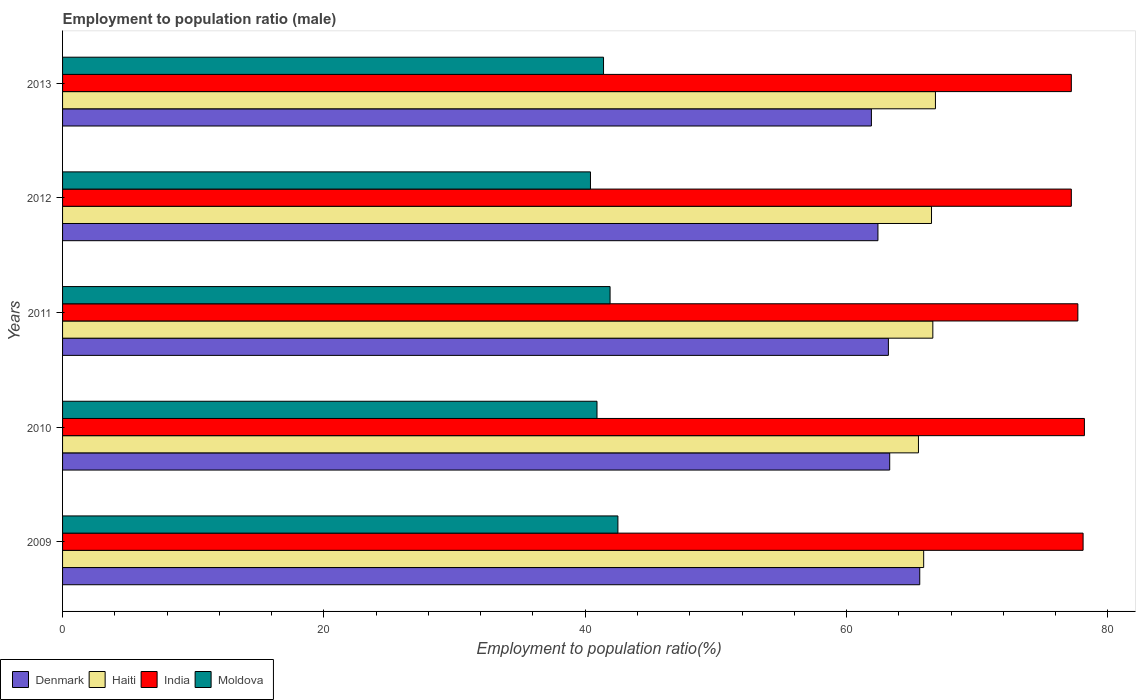How many different coloured bars are there?
Keep it short and to the point. 4. How many groups of bars are there?
Give a very brief answer. 5. Are the number of bars on each tick of the Y-axis equal?
Give a very brief answer. Yes. What is the label of the 3rd group of bars from the top?
Provide a short and direct response. 2011. In how many cases, is the number of bars for a given year not equal to the number of legend labels?
Your answer should be compact. 0. What is the employment to population ratio in Haiti in 2010?
Your response must be concise. 65.5. Across all years, what is the maximum employment to population ratio in India?
Make the answer very short. 78.2. Across all years, what is the minimum employment to population ratio in Haiti?
Ensure brevity in your answer.  65.5. What is the total employment to population ratio in Denmark in the graph?
Your answer should be very brief. 316.4. What is the difference between the employment to population ratio in Haiti in 2010 and that in 2013?
Provide a succinct answer. -1.3. What is the difference between the employment to population ratio in Haiti in 2010 and the employment to population ratio in Denmark in 2013?
Your response must be concise. 3.6. What is the average employment to population ratio in Haiti per year?
Make the answer very short. 66.26. In how many years, is the employment to population ratio in Denmark greater than 36 %?
Offer a terse response. 5. What is the ratio of the employment to population ratio in Denmark in 2009 to that in 2011?
Ensure brevity in your answer.  1.04. Is the employment to population ratio in Haiti in 2009 less than that in 2011?
Make the answer very short. Yes. Is the difference between the employment to population ratio in Denmark in 2010 and 2013 greater than the difference between the employment to population ratio in Moldova in 2010 and 2013?
Ensure brevity in your answer.  Yes. What is the difference between the highest and the second highest employment to population ratio in Denmark?
Provide a short and direct response. 2.3. What is the difference between the highest and the lowest employment to population ratio in Moldova?
Your answer should be very brief. 2.1. In how many years, is the employment to population ratio in India greater than the average employment to population ratio in India taken over all years?
Provide a short and direct response. 3. Is the sum of the employment to population ratio in India in 2009 and 2013 greater than the maximum employment to population ratio in Denmark across all years?
Offer a terse response. Yes. What does the 2nd bar from the top in 2009 represents?
Your answer should be very brief. India. What does the 1st bar from the bottom in 2010 represents?
Offer a very short reply. Denmark. Are all the bars in the graph horizontal?
Give a very brief answer. Yes. How many years are there in the graph?
Make the answer very short. 5. Does the graph contain any zero values?
Offer a terse response. No. Does the graph contain grids?
Offer a very short reply. No. How are the legend labels stacked?
Make the answer very short. Horizontal. What is the title of the graph?
Give a very brief answer. Employment to population ratio (male). Does "Sub-Saharan Africa (developing only)" appear as one of the legend labels in the graph?
Provide a succinct answer. No. What is the label or title of the X-axis?
Your response must be concise. Employment to population ratio(%). What is the Employment to population ratio(%) in Denmark in 2009?
Offer a terse response. 65.6. What is the Employment to population ratio(%) of Haiti in 2009?
Your answer should be very brief. 65.9. What is the Employment to population ratio(%) of India in 2009?
Your response must be concise. 78.1. What is the Employment to population ratio(%) in Moldova in 2009?
Offer a terse response. 42.5. What is the Employment to population ratio(%) of Denmark in 2010?
Offer a terse response. 63.3. What is the Employment to population ratio(%) of Haiti in 2010?
Your answer should be very brief. 65.5. What is the Employment to population ratio(%) of India in 2010?
Your response must be concise. 78.2. What is the Employment to population ratio(%) in Moldova in 2010?
Your answer should be very brief. 40.9. What is the Employment to population ratio(%) of Denmark in 2011?
Offer a very short reply. 63.2. What is the Employment to population ratio(%) in Haiti in 2011?
Offer a terse response. 66.6. What is the Employment to population ratio(%) of India in 2011?
Offer a very short reply. 77.7. What is the Employment to population ratio(%) of Moldova in 2011?
Your response must be concise. 41.9. What is the Employment to population ratio(%) of Denmark in 2012?
Keep it short and to the point. 62.4. What is the Employment to population ratio(%) of Haiti in 2012?
Your answer should be compact. 66.5. What is the Employment to population ratio(%) of India in 2012?
Make the answer very short. 77.2. What is the Employment to population ratio(%) of Moldova in 2012?
Provide a succinct answer. 40.4. What is the Employment to population ratio(%) of Denmark in 2013?
Keep it short and to the point. 61.9. What is the Employment to population ratio(%) of Haiti in 2013?
Provide a succinct answer. 66.8. What is the Employment to population ratio(%) of India in 2013?
Your answer should be compact. 77.2. What is the Employment to population ratio(%) in Moldova in 2013?
Your answer should be very brief. 41.4. Across all years, what is the maximum Employment to population ratio(%) of Denmark?
Offer a terse response. 65.6. Across all years, what is the maximum Employment to population ratio(%) of Haiti?
Make the answer very short. 66.8. Across all years, what is the maximum Employment to population ratio(%) of India?
Make the answer very short. 78.2. Across all years, what is the maximum Employment to population ratio(%) in Moldova?
Provide a succinct answer. 42.5. Across all years, what is the minimum Employment to population ratio(%) of Denmark?
Your answer should be compact. 61.9. Across all years, what is the minimum Employment to population ratio(%) in Haiti?
Your answer should be compact. 65.5. Across all years, what is the minimum Employment to population ratio(%) in India?
Provide a succinct answer. 77.2. Across all years, what is the minimum Employment to population ratio(%) of Moldova?
Your answer should be very brief. 40.4. What is the total Employment to population ratio(%) of Denmark in the graph?
Keep it short and to the point. 316.4. What is the total Employment to population ratio(%) of Haiti in the graph?
Keep it short and to the point. 331.3. What is the total Employment to population ratio(%) of India in the graph?
Give a very brief answer. 388.4. What is the total Employment to population ratio(%) of Moldova in the graph?
Provide a short and direct response. 207.1. What is the difference between the Employment to population ratio(%) in Denmark in 2009 and that in 2010?
Your response must be concise. 2.3. What is the difference between the Employment to population ratio(%) in Haiti in 2009 and that in 2011?
Provide a short and direct response. -0.7. What is the difference between the Employment to population ratio(%) in Denmark in 2009 and that in 2012?
Your answer should be very brief. 3.2. What is the difference between the Employment to population ratio(%) of Haiti in 2009 and that in 2012?
Your answer should be compact. -0.6. What is the difference between the Employment to population ratio(%) in Moldova in 2009 and that in 2012?
Offer a terse response. 2.1. What is the difference between the Employment to population ratio(%) in Denmark in 2009 and that in 2013?
Offer a very short reply. 3.7. What is the difference between the Employment to population ratio(%) in Denmark in 2010 and that in 2011?
Give a very brief answer. 0.1. What is the difference between the Employment to population ratio(%) in Haiti in 2010 and that in 2011?
Make the answer very short. -1.1. What is the difference between the Employment to population ratio(%) in India in 2010 and that in 2011?
Your answer should be very brief. 0.5. What is the difference between the Employment to population ratio(%) in Moldova in 2010 and that in 2011?
Provide a short and direct response. -1. What is the difference between the Employment to population ratio(%) in Denmark in 2010 and that in 2012?
Keep it short and to the point. 0.9. What is the difference between the Employment to population ratio(%) of India in 2010 and that in 2012?
Provide a succinct answer. 1. What is the difference between the Employment to population ratio(%) in Denmark in 2010 and that in 2013?
Your response must be concise. 1.4. What is the difference between the Employment to population ratio(%) of India in 2010 and that in 2013?
Offer a terse response. 1. What is the difference between the Employment to population ratio(%) of Denmark in 2011 and that in 2012?
Ensure brevity in your answer.  0.8. What is the difference between the Employment to population ratio(%) in Haiti in 2011 and that in 2012?
Offer a terse response. 0.1. What is the difference between the Employment to population ratio(%) in India in 2011 and that in 2012?
Keep it short and to the point. 0.5. What is the difference between the Employment to population ratio(%) in Moldova in 2011 and that in 2012?
Offer a very short reply. 1.5. What is the difference between the Employment to population ratio(%) in India in 2011 and that in 2013?
Keep it short and to the point. 0.5. What is the difference between the Employment to population ratio(%) in Moldova in 2011 and that in 2013?
Provide a short and direct response. 0.5. What is the difference between the Employment to population ratio(%) in Denmark in 2009 and the Employment to population ratio(%) in Moldova in 2010?
Provide a succinct answer. 24.7. What is the difference between the Employment to population ratio(%) in Haiti in 2009 and the Employment to population ratio(%) in India in 2010?
Offer a terse response. -12.3. What is the difference between the Employment to population ratio(%) of Haiti in 2009 and the Employment to population ratio(%) of Moldova in 2010?
Your answer should be very brief. 25. What is the difference between the Employment to population ratio(%) in India in 2009 and the Employment to population ratio(%) in Moldova in 2010?
Your answer should be very brief. 37.2. What is the difference between the Employment to population ratio(%) in Denmark in 2009 and the Employment to population ratio(%) in Haiti in 2011?
Your response must be concise. -1. What is the difference between the Employment to population ratio(%) of Denmark in 2009 and the Employment to population ratio(%) of India in 2011?
Your answer should be compact. -12.1. What is the difference between the Employment to population ratio(%) in Denmark in 2009 and the Employment to population ratio(%) in Moldova in 2011?
Your answer should be very brief. 23.7. What is the difference between the Employment to population ratio(%) in India in 2009 and the Employment to population ratio(%) in Moldova in 2011?
Give a very brief answer. 36.2. What is the difference between the Employment to population ratio(%) in Denmark in 2009 and the Employment to population ratio(%) in India in 2012?
Offer a very short reply. -11.6. What is the difference between the Employment to population ratio(%) in Denmark in 2009 and the Employment to population ratio(%) in Moldova in 2012?
Provide a succinct answer. 25.2. What is the difference between the Employment to population ratio(%) of Haiti in 2009 and the Employment to population ratio(%) of India in 2012?
Your answer should be very brief. -11.3. What is the difference between the Employment to population ratio(%) of Haiti in 2009 and the Employment to population ratio(%) of Moldova in 2012?
Ensure brevity in your answer.  25.5. What is the difference between the Employment to population ratio(%) of India in 2009 and the Employment to population ratio(%) of Moldova in 2012?
Your response must be concise. 37.7. What is the difference between the Employment to population ratio(%) in Denmark in 2009 and the Employment to population ratio(%) in Haiti in 2013?
Make the answer very short. -1.2. What is the difference between the Employment to population ratio(%) of Denmark in 2009 and the Employment to population ratio(%) of Moldova in 2013?
Your response must be concise. 24.2. What is the difference between the Employment to population ratio(%) in Haiti in 2009 and the Employment to population ratio(%) in India in 2013?
Provide a short and direct response. -11.3. What is the difference between the Employment to population ratio(%) of India in 2009 and the Employment to population ratio(%) of Moldova in 2013?
Keep it short and to the point. 36.7. What is the difference between the Employment to population ratio(%) of Denmark in 2010 and the Employment to population ratio(%) of India in 2011?
Keep it short and to the point. -14.4. What is the difference between the Employment to population ratio(%) of Denmark in 2010 and the Employment to population ratio(%) of Moldova in 2011?
Your answer should be very brief. 21.4. What is the difference between the Employment to population ratio(%) of Haiti in 2010 and the Employment to population ratio(%) of Moldova in 2011?
Your response must be concise. 23.6. What is the difference between the Employment to population ratio(%) of India in 2010 and the Employment to population ratio(%) of Moldova in 2011?
Provide a short and direct response. 36.3. What is the difference between the Employment to population ratio(%) in Denmark in 2010 and the Employment to population ratio(%) in Haiti in 2012?
Keep it short and to the point. -3.2. What is the difference between the Employment to population ratio(%) in Denmark in 2010 and the Employment to population ratio(%) in Moldova in 2012?
Your response must be concise. 22.9. What is the difference between the Employment to population ratio(%) of Haiti in 2010 and the Employment to population ratio(%) of India in 2012?
Make the answer very short. -11.7. What is the difference between the Employment to population ratio(%) in Haiti in 2010 and the Employment to population ratio(%) in Moldova in 2012?
Keep it short and to the point. 25.1. What is the difference between the Employment to population ratio(%) of India in 2010 and the Employment to population ratio(%) of Moldova in 2012?
Your answer should be compact. 37.8. What is the difference between the Employment to population ratio(%) of Denmark in 2010 and the Employment to population ratio(%) of India in 2013?
Ensure brevity in your answer.  -13.9. What is the difference between the Employment to population ratio(%) of Denmark in 2010 and the Employment to population ratio(%) of Moldova in 2013?
Offer a terse response. 21.9. What is the difference between the Employment to population ratio(%) in Haiti in 2010 and the Employment to population ratio(%) in India in 2013?
Offer a very short reply. -11.7. What is the difference between the Employment to population ratio(%) of Haiti in 2010 and the Employment to population ratio(%) of Moldova in 2013?
Provide a short and direct response. 24.1. What is the difference between the Employment to population ratio(%) of India in 2010 and the Employment to population ratio(%) of Moldova in 2013?
Your answer should be very brief. 36.8. What is the difference between the Employment to population ratio(%) in Denmark in 2011 and the Employment to population ratio(%) in Haiti in 2012?
Keep it short and to the point. -3.3. What is the difference between the Employment to population ratio(%) of Denmark in 2011 and the Employment to population ratio(%) of India in 2012?
Offer a terse response. -14. What is the difference between the Employment to population ratio(%) of Denmark in 2011 and the Employment to population ratio(%) of Moldova in 2012?
Offer a very short reply. 22.8. What is the difference between the Employment to population ratio(%) in Haiti in 2011 and the Employment to population ratio(%) in Moldova in 2012?
Ensure brevity in your answer.  26.2. What is the difference between the Employment to population ratio(%) of India in 2011 and the Employment to population ratio(%) of Moldova in 2012?
Offer a terse response. 37.3. What is the difference between the Employment to population ratio(%) in Denmark in 2011 and the Employment to population ratio(%) in India in 2013?
Offer a very short reply. -14. What is the difference between the Employment to population ratio(%) of Denmark in 2011 and the Employment to population ratio(%) of Moldova in 2013?
Keep it short and to the point. 21.8. What is the difference between the Employment to population ratio(%) in Haiti in 2011 and the Employment to population ratio(%) in India in 2013?
Provide a succinct answer. -10.6. What is the difference between the Employment to population ratio(%) in Haiti in 2011 and the Employment to population ratio(%) in Moldova in 2013?
Keep it short and to the point. 25.2. What is the difference between the Employment to population ratio(%) in India in 2011 and the Employment to population ratio(%) in Moldova in 2013?
Make the answer very short. 36.3. What is the difference between the Employment to population ratio(%) in Denmark in 2012 and the Employment to population ratio(%) in India in 2013?
Your answer should be compact. -14.8. What is the difference between the Employment to population ratio(%) of Haiti in 2012 and the Employment to population ratio(%) of India in 2013?
Your response must be concise. -10.7. What is the difference between the Employment to population ratio(%) of Haiti in 2012 and the Employment to population ratio(%) of Moldova in 2013?
Your answer should be very brief. 25.1. What is the difference between the Employment to population ratio(%) in India in 2012 and the Employment to population ratio(%) in Moldova in 2013?
Your answer should be compact. 35.8. What is the average Employment to population ratio(%) of Denmark per year?
Your answer should be very brief. 63.28. What is the average Employment to population ratio(%) in Haiti per year?
Give a very brief answer. 66.26. What is the average Employment to population ratio(%) in India per year?
Provide a short and direct response. 77.68. What is the average Employment to population ratio(%) of Moldova per year?
Make the answer very short. 41.42. In the year 2009, what is the difference between the Employment to population ratio(%) of Denmark and Employment to population ratio(%) of Haiti?
Provide a short and direct response. -0.3. In the year 2009, what is the difference between the Employment to population ratio(%) in Denmark and Employment to population ratio(%) in Moldova?
Your answer should be very brief. 23.1. In the year 2009, what is the difference between the Employment to population ratio(%) in Haiti and Employment to population ratio(%) in Moldova?
Make the answer very short. 23.4. In the year 2009, what is the difference between the Employment to population ratio(%) of India and Employment to population ratio(%) of Moldova?
Give a very brief answer. 35.6. In the year 2010, what is the difference between the Employment to population ratio(%) in Denmark and Employment to population ratio(%) in India?
Offer a very short reply. -14.9. In the year 2010, what is the difference between the Employment to population ratio(%) of Denmark and Employment to population ratio(%) of Moldova?
Provide a succinct answer. 22.4. In the year 2010, what is the difference between the Employment to population ratio(%) in Haiti and Employment to population ratio(%) in Moldova?
Your answer should be compact. 24.6. In the year 2010, what is the difference between the Employment to population ratio(%) of India and Employment to population ratio(%) of Moldova?
Your response must be concise. 37.3. In the year 2011, what is the difference between the Employment to population ratio(%) in Denmark and Employment to population ratio(%) in Haiti?
Ensure brevity in your answer.  -3.4. In the year 2011, what is the difference between the Employment to population ratio(%) of Denmark and Employment to population ratio(%) of Moldova?
Your response must be concise. 21.3. In the year 2011, what is the difference between the Employment to population ratio(%) in Haiti and Employment to population ratio(%) in Moldova?
Provide a succinct answer. 24.7. In the year 2011, what is the difference between the Employment to population ratio(%) in India and Employment to population ratio(%) in Moldova?
Your answer should be compact. 35.8. In the year 2012, what is the difference between the Employment to population ratio(%) of Denmark and Employment to population ratio(%) of India?
Give a very brief answer. -14.8. In the year 2012, what is the difference between the Employment to population ratio(%) of Denmark and Employment to population ratio(%) of Moldova?
Offer a very short reply. 22. In the year 2012, what is the difference between the Employment to population ratio(%) in Haiti and Employment to population ratio(%) in Moldova?
Provide a succinct answer. 26.1. In the year 2012, what is the difference between the Employment to population ratio(%) in India and Employment to population ratio(%) in Moldova?
Ensure brevity in your answer.  36.8. In the year 2013, what is the difference between the Employment to population ratio(%) of Denmark and Employment to population ratio(%) of India?
Keep it short and to the point. -15.3. In the year 2013, what is the difference between the Employment to population ratio(%) of Denmark and Employment to population ratio(%) of Moldova?
Your answer should be compact. 20.5. In the year 2013, what is the difference between the Employment to population ratio(%) in Haiti and Employment to population ratio(%) in India?
Your answer should be compact. -10.4. In the year 2013, what is the difference between the Employment to population ratio(%) of Haiti and Employment to population ratio(%) of Moldova?
Provide a succinct answer. 25.4. In the year 2013, what is the difference between the Employment to population ratio(%) in India and Employment to population ratio(%) in Moldova?
Give a very brief answer. 35.8. What is the ratio of the Employment to population ratio(%) in Denmark in 2009 to that in 2010?
Keep it short and to the point. 1.04. What is the ratio of the Employment to population ratio(%) in Haiti in 2009 to that in 2010?
Give a very brief answer. 1.01. What is the ratio of the Employment to population ratio(%) of India in 2009 to that in 2010?
Provide a short and direct response. 1. What is the ratio of the Employment to population ratio(%) of Moldova in 2009 to that in 2010?
Keep it short and to the point. 1.04. What is the ratio of the Employment to population ratio(%) in Denmark in 2009 to that in 2011?
Provide a short and direct response. 1.04. What is the ratio of the Employment to population ratio(%) of Haiti in 2009 to that in 2011?
Make the answer very short. 0.99. What is the ratio of the Employment to population ratio(%) in Moldova in 2009 to that in 2011?
Ensure brevity in your answer.  1.01. What is the ratio of the Employment to population ratio(%) in Denmark in 2009 to that in 2012?
Make the answer very short. 1.05. What is the ratio of the Employment to population ratio(%) in India in 2009 to that in 2012?
Your answer should be compact. 1.01. What is the ratio of the Employment to population ratio(%) of Moldova in 2009 to that in 2012?
Your answer should be very brief. 1.05. What is the ratio of the Employment to population ratio(%) of Denmark in 2009 to that in 2013?
Give a very brief answer. 1.06. What is the ratio of the Employment to population ratio(%) of Haiti in 2009 to that in 2013?
Keep it short and to the point. 0.99. What is the ratio of the Employment to population ratio(%) of India in 2009 to that in 2013?
Provide a succinct answer. 1.01. What is the ratio of the Employment to population ratio(%) in Moldova in 2009 to that in 2013?
Provide a succinct answer. 1.03. What is the ratio of the Employment to population ratio(%) in Haiti in 2010 to that in 2011?
Your answer should be very brief. 0.98. What is the ratio of the Employment to population ratio(%) in India in 2010 to that in 2011?
Offer a terse response. 1.01. What is the ratio of the Employment to population ratio(%) of Moldova in 2010 to that in 2011?
Provide a short and direct response. 0.98. What is the ratio of the Employment to population ratio(%) in Denmark in 2010 to that in 2012?
Your answer should be compact. 1.01. What is the ratio of the Employment to population ratio(%) in Moldova in 2010 to that in 2012?
Your answer should be compact. 1.01. What is the ratio of the Employment to population ratio(%) of Denmark in 2010 to that in 2013?
Make the answer very short. 1.02. What is the ratio of the Employment to population ratio(%) in Haiti in 2010 to that in 2013?
Ensure brevity in your answer.  0.98. What is the ratio of the Employment to population ratio(%) in India in 2010 to that in 2013?
Provide a succinct answer. 1.01. What is the ratio of the Employment to population ratio(%) of Moldova in 2010 to that in 2013?
Your answer should be very brief. 0.99. What is the ratio of the Employment to population ratio(%) of Denmark in 2011 to that in 2012?
Ensure brevity in your answer.  1.01. What is the ratio of the Employment to population ratio(%) of Haiti in 2011 to that in 2012?
Keep it short and to the point. 1. What is the ratio of the Employment to population ratio(%) of Moldova in 2011 to that in 2012?
Your response must be concise. 1.04. What is the ratio of the Employment to population ratio(%) of Denmark in 2011 to that in 2013?
Offer a very short reply. 1.02. What is the ratio of the Employment to population ratio(%) in Haiti in 2011 to that in 2013?
Give a very brief answer. 1. What is the ratio of the Employment to population ratio(%) of Moldova in 2011 to that in 2013?
Keep it short and to the point. 1.01. What is the ratio of the Employment to population ratio(%) of Denmark in 2012 to that in 2013?
Ensure brevity in your answer.  1.01. What is the ratio of the Employment to population ratio(%) in India in 2012 to that in 2013?
Your answer should be compact. 1. What is the ratio of the Employment to population ratio(%) of Moldova in 2012 to that in 2013?
Offer a very short reply. 0.98. What is the difference between the highest and the second highest Employment to population ratio(%) in India?
Provide a short and direct response. 0.1. What is the difference between the highest and the second highest Employment to population ratio(%) in Moldova?
Provide a short and direct response. 0.6. What is the difference between the highest and the lowest Employment to population ratio(%) in Denmark?
Your answer should be very brief. 3.7. What is the difference between the highest and the lowest Employment to population ratio(%) of Haiti?
Your answer should be compact. 1.3. What is the difference between the highest and the lowest Employment to population ratio(%) in India?
Your response must be concise. 1. What is the difference between the highest and the lowest Employment to population ratio(%) in Moldova?
Your answer should be compact. 2.1. 